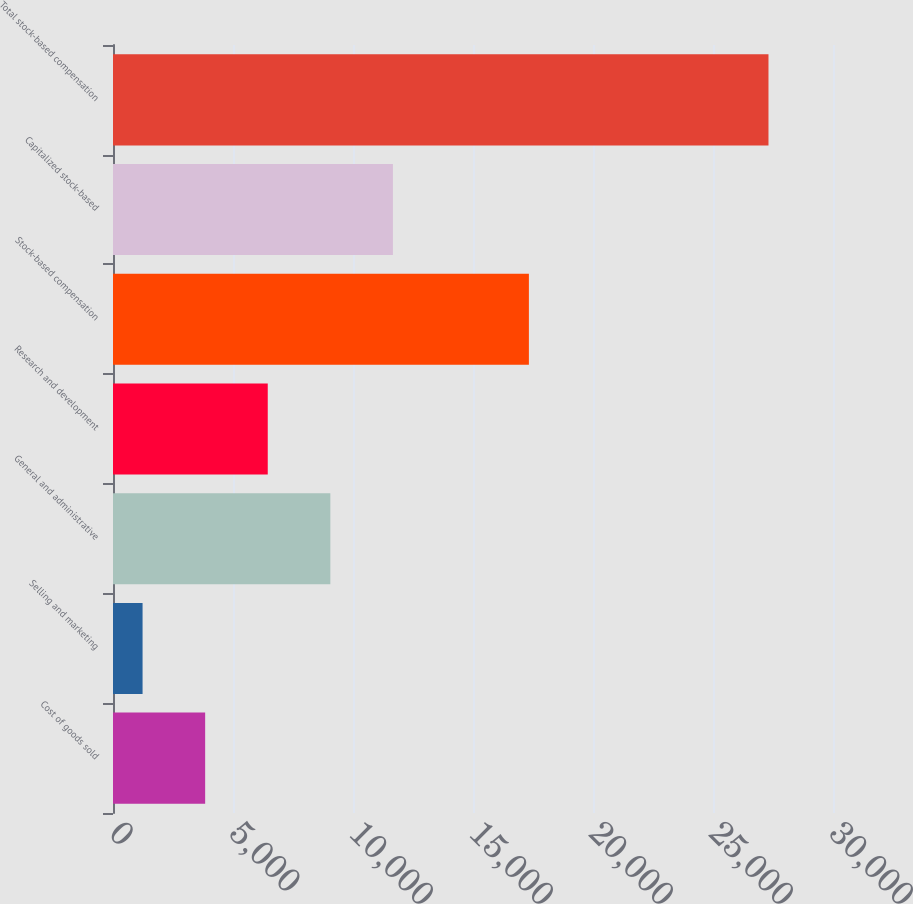Convert chart to OTSL. <chart><loc_0><loc_0><loc_500><loc_500><bar_chart><fcel>Cost of goods sold<fcel>Selling and marketing<fcel>General and administrative<fcel>Research and development<fcel>Stock-based compensation<fcel>Capitalized stock-based<fcel>Total stock-based compensation<nl><fcel>3840<fcel>1232<fcel>9056<fcel>6448<fcel>17329<fcel>11664<fcel>27312<nl></chart> 